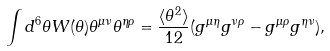Convert formula to latex. <formula><loc_0><loc_0><loc_500><loc_500>\int d ^ { 6 } \theta W ( \theta ) \theta ^ { \mu \nu } \theta ^ { \eta \rho } = \frac { \langle \theta ^ { 2 } \rangle } { 1 2 } ( g ^ { \mu \eta } g ^ { \nu \rho } - g ^ { \mu \rho } g ^ { \eta \nu } ) ,</formula> 